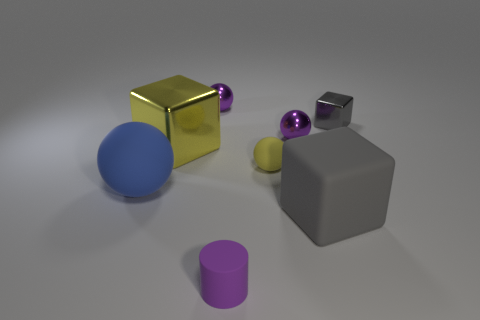How would you describe the texture of the yellow object? The yellow object has a smooth, shiny surface that suggests it's made of metal. The reflections on its surface indicate that it's quite polished, giving it a glossy appearance. 